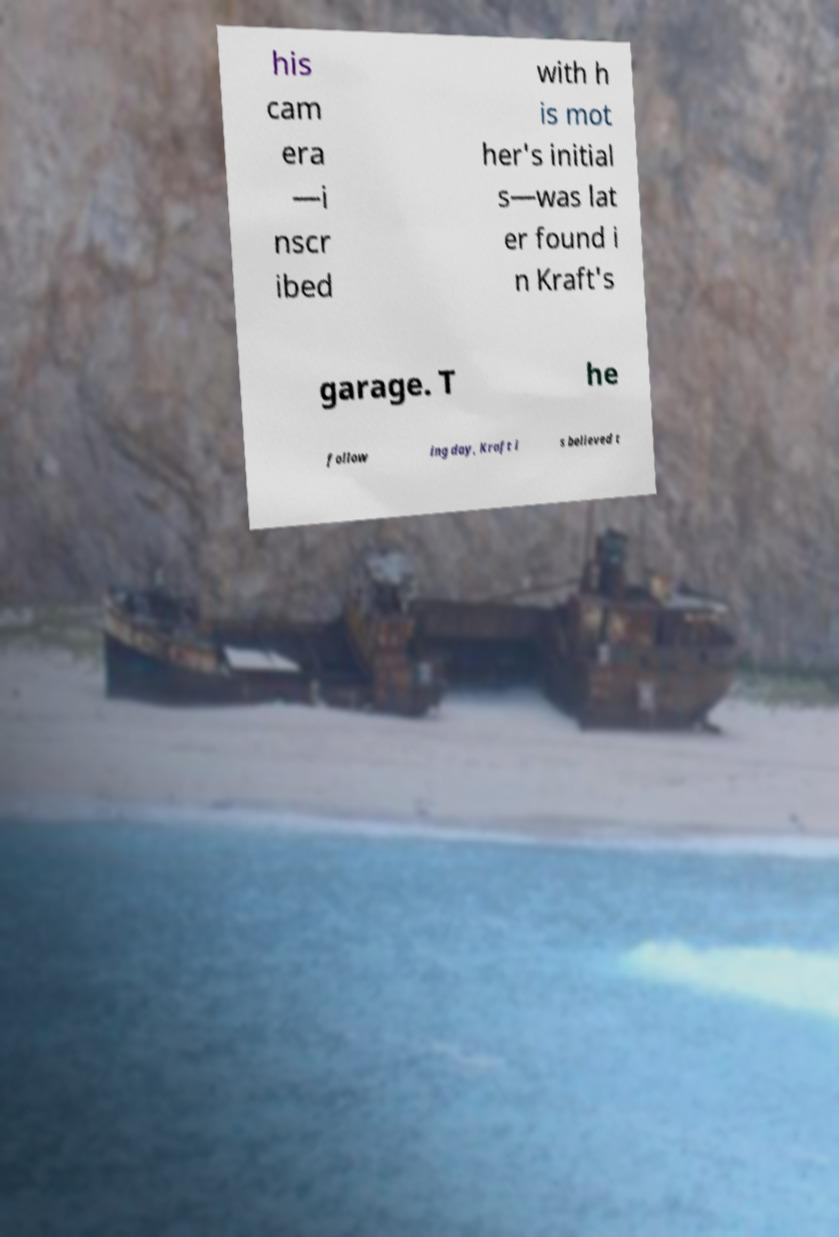Could you extract and type out the text from this image? his cam era —i nscr ibed with h is mot her's initial s—was lat er found i n Kraft's garage. T he follow ing day, Kraft i s believed t 